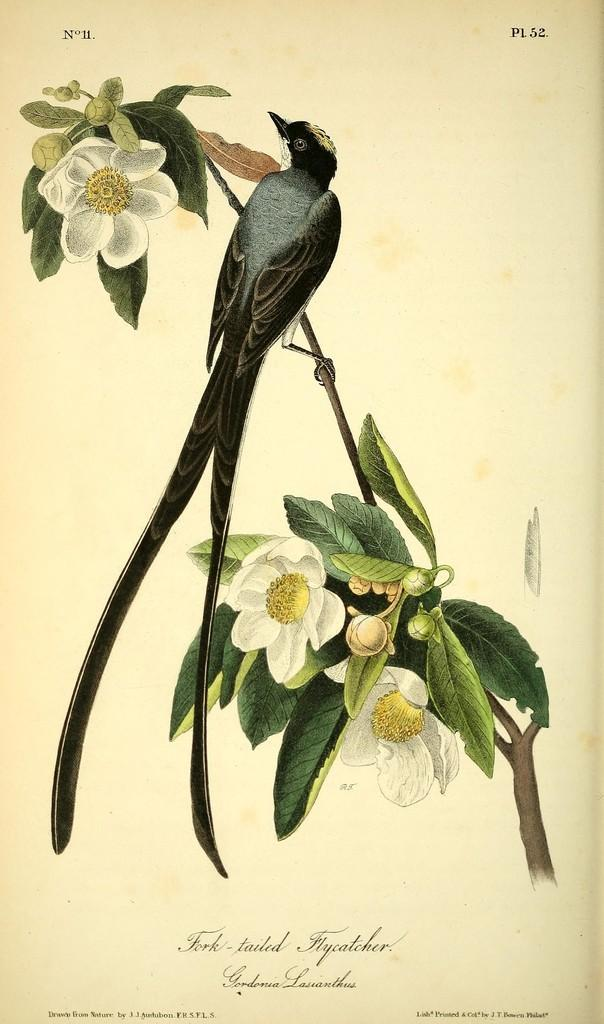What is the main subject of the image? The image contains a painting. What elements are included in the painting? The painting includes leaves, flowers, buds, stems, and a bird sitting on a stem. Is there any text present in the image? Yes, there is text at the bottom of the painting. What type of fish can be seen swimming in the painting? There is no fish present in the painting; it features a bird sitting on a stem. What type of joke is being told by the flowers in the painting? There is no joke being told by the flowers in the painting; they are simply depicted as part of the artwork. 